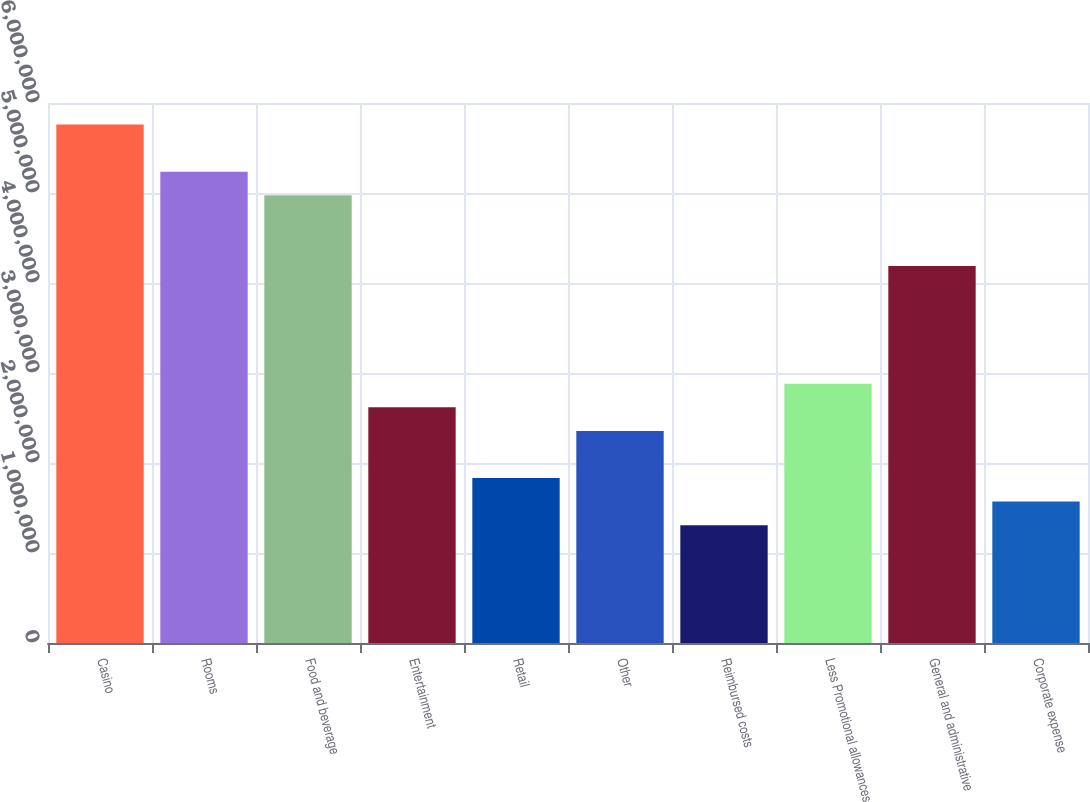Convert chart. <chart><loc_0><loc_0><loc_500><loc_500><bar_chart><fcel>Casino<fcel>Rooms<fcel>Food and beverage<fcel>Entertainment<fcel>Retail<fcel>Other<fcel>Reimbursed costs<fcel>Less Promotional allowances<fcel>General and administrative<fcel>Corporate expense<nl><fcel>5.75973e+06<fcel>5.23612e+06<fcel>4.97431e+06<fcel>2.61806e+06<fcel>1.83264e+06<fcel>2.35625e+06<fcel>1.30903e+06<fcel>2.87987e+06<fcel>4.18889e+06<fcel>1.57084e+06<nl></chart> 